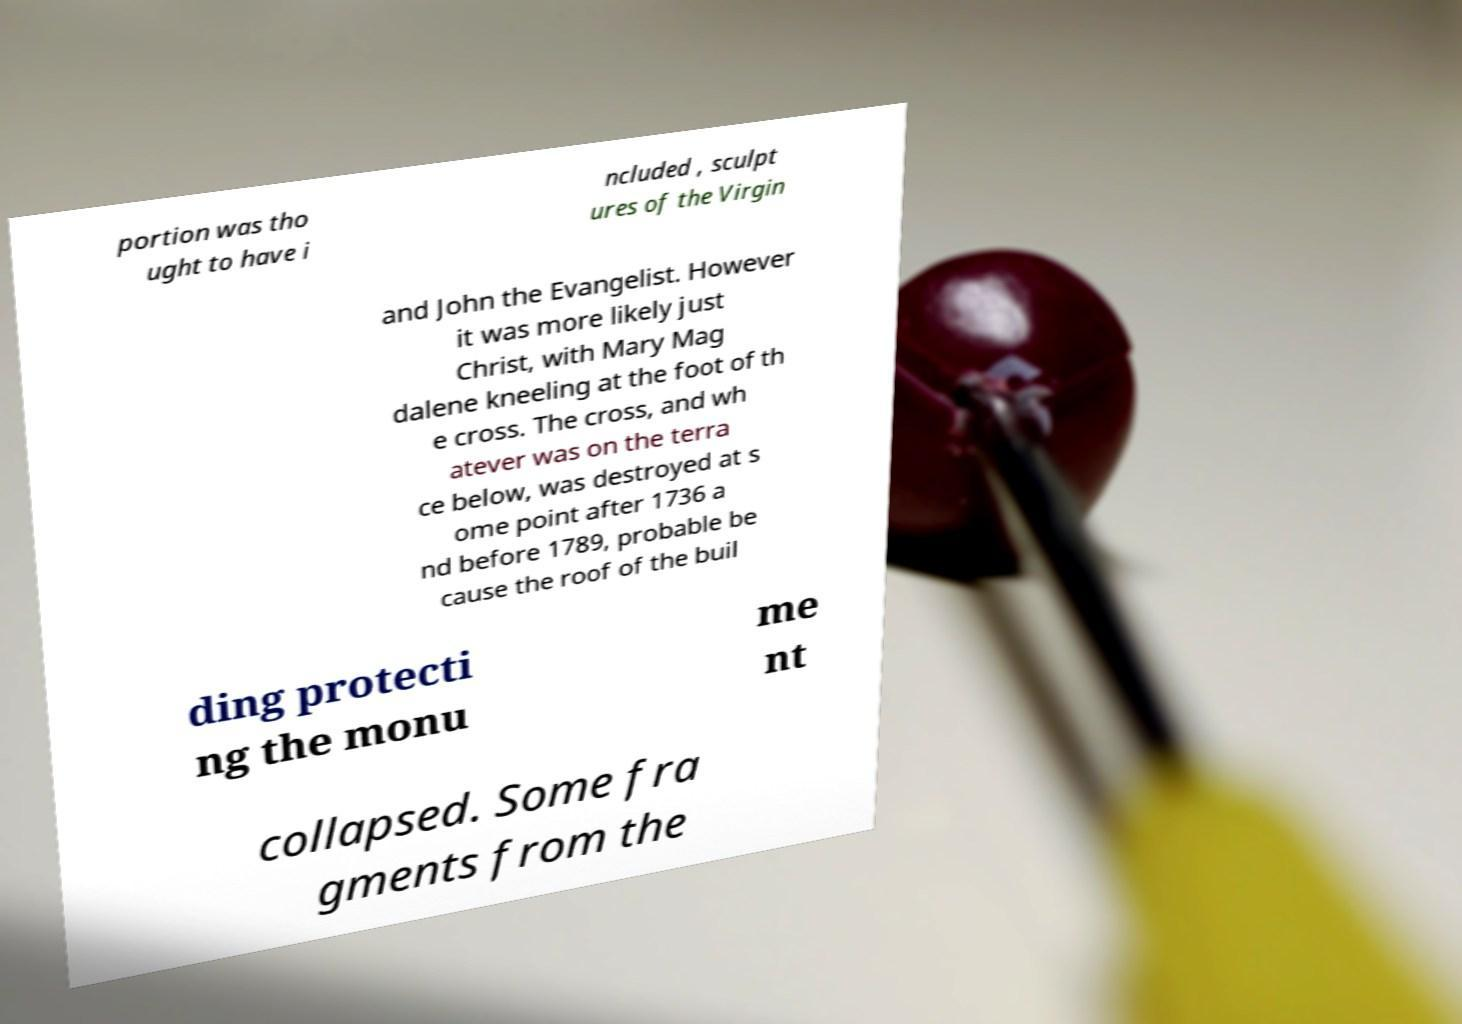Please read and relay the text visible in this image. What does it say? portion was tho ught to have i ncluded , sculpt ures of the Virgin and John the Evangelist. However it was more likely just Christ, with Mary Mag dalene kneeling at the foot of th e cross. The cross, and wh atever was on the terra ce below, was destroyed at s ome point after 1736 a nd before 1789, probable be cause the roof of the buil ding protecti ng the monu me nt collapsed. Some fra gments from the 